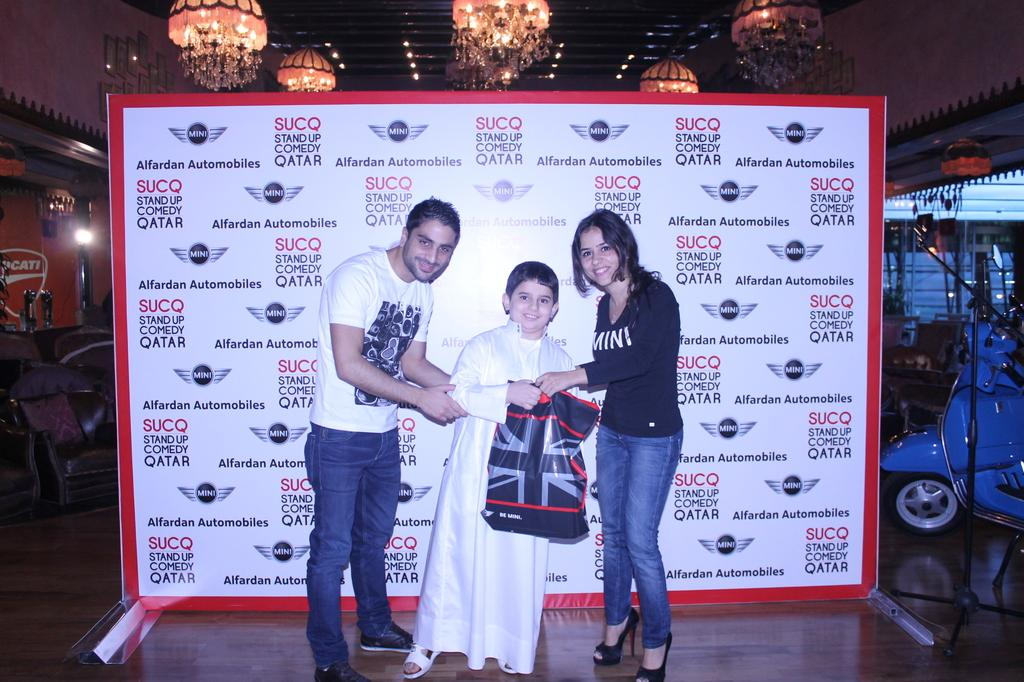<image>
Relay a brief, clear account of the picture shown. A fan meeting some people in front of an Alfardan Automobiles advertisement in Qatar. 